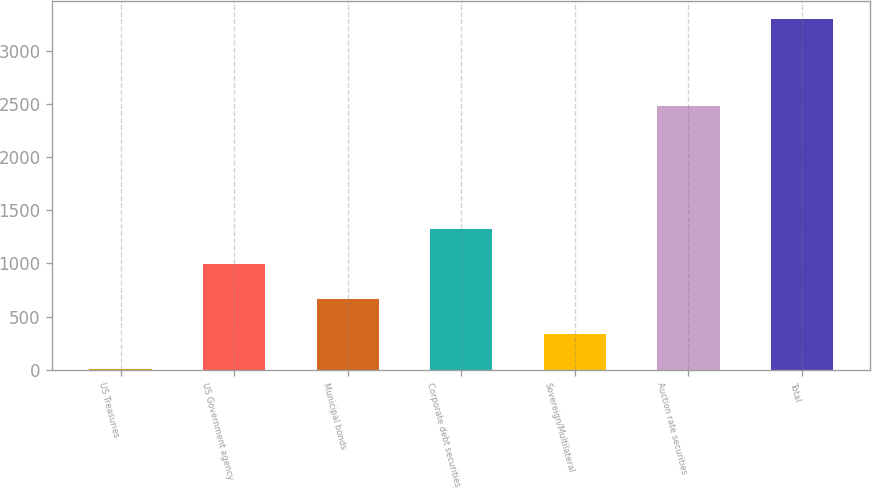Convert chart. <chart><loc_0><loc_0><loc_500><loc_500><bar_chart><fcel>US Treasuries<fcel>US Government agency<fcel>Municipal bonds<fcel>Corporate debt securities<fcel>Sovereign/Multilateral<fcel>Auction rate securities<fcel>Total<nl><fcel>7<fcel>994.9<fcel>665.6<fcel>1324.2<fcel>336.3<fcel>2482<fcel>3300<nl></chart> 